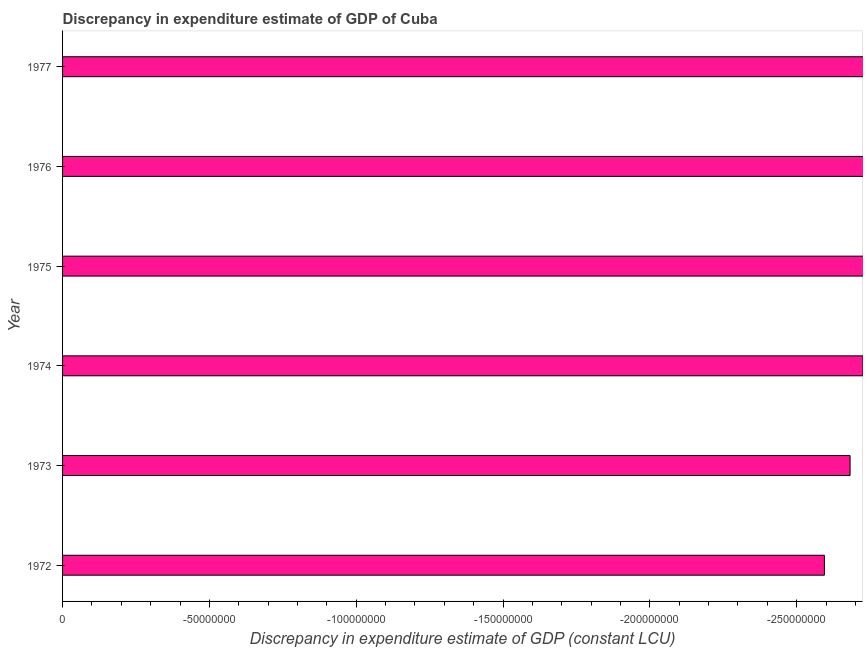Does the graph contain any zero values?
Ensure brevity in your answer.  Yes. What is the title of the graph?
Offer a terse response. Discrepancy in expenditure estimate of GDP of Cuba. What is the label or title of the X-axis?
Ensure brevity in your answer.  Discrepancy in expenditure estimate of GDP (constant LCU). What is the label or title of the Y-axis?
Ensure brevity in your answer.  Year. What is the discrepancy in expenditure estimate of gdp in 1974?
Your response must be concise. 0. Across all years, what is the minimum discrepancy in expenditure estimate of gdp?
Provide a short and direct response. 0. What is the median discrepancy in expenditure estimate of gdp?
Provide a short and direct response. 0. In how many years, is the discrepancy in expenditure estimate of gdp greater than -130000000 LCU?
Your answer should be compact. 0. In how many years, is the discrepancy in expenditure estimate of gdp greater than the average discrepancy in expenditure estimate of gdp taken over all years?
Provide a succinct answer. 0. Are all the bars in the graph horizontal?
Provide a succinct answer. Yes. How many years are there in the graph?
Provide a short and direct response. 6. Are the values on the major ticks of X-axis written in scientific E-notation?
Your answer should be compact. No. What is the Discrepancy in expenditure estimate of GDP (constant LCU) of 1972?
Offer a terse response. 0. What is the Discrepancy in expenditure estimate of GDP (constant LCU) in 1973?
Make the answer very short. 0. What is the Discrepancy in expenditure estimate of GDP (constant LCU) of 1975?
Make the answer very short. 0. What is the Discrepancy in expenditure estimate of GDP (constant LCU) of 1976?
Make the answer very short. 0. 